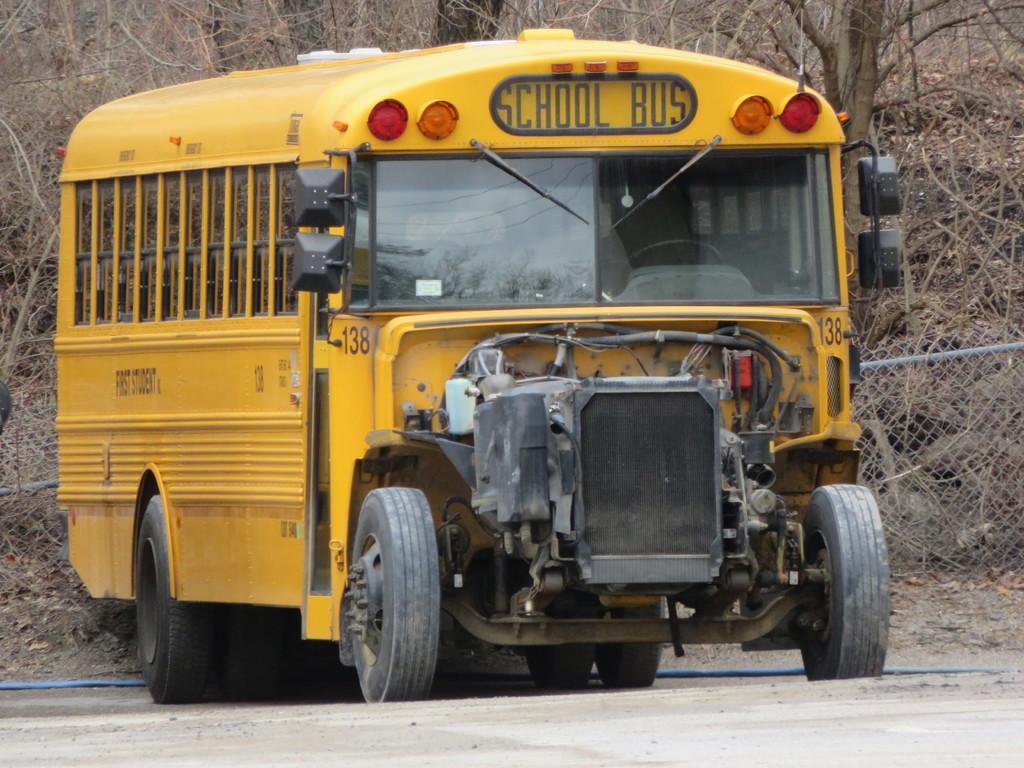Can you describe this image briefly? In this image we can see one yellow color school bus, one fence behind the school bus, some text on the school bus, one black object on the left side of the image, some dried leaves on the ground and some dried trees in the background. 